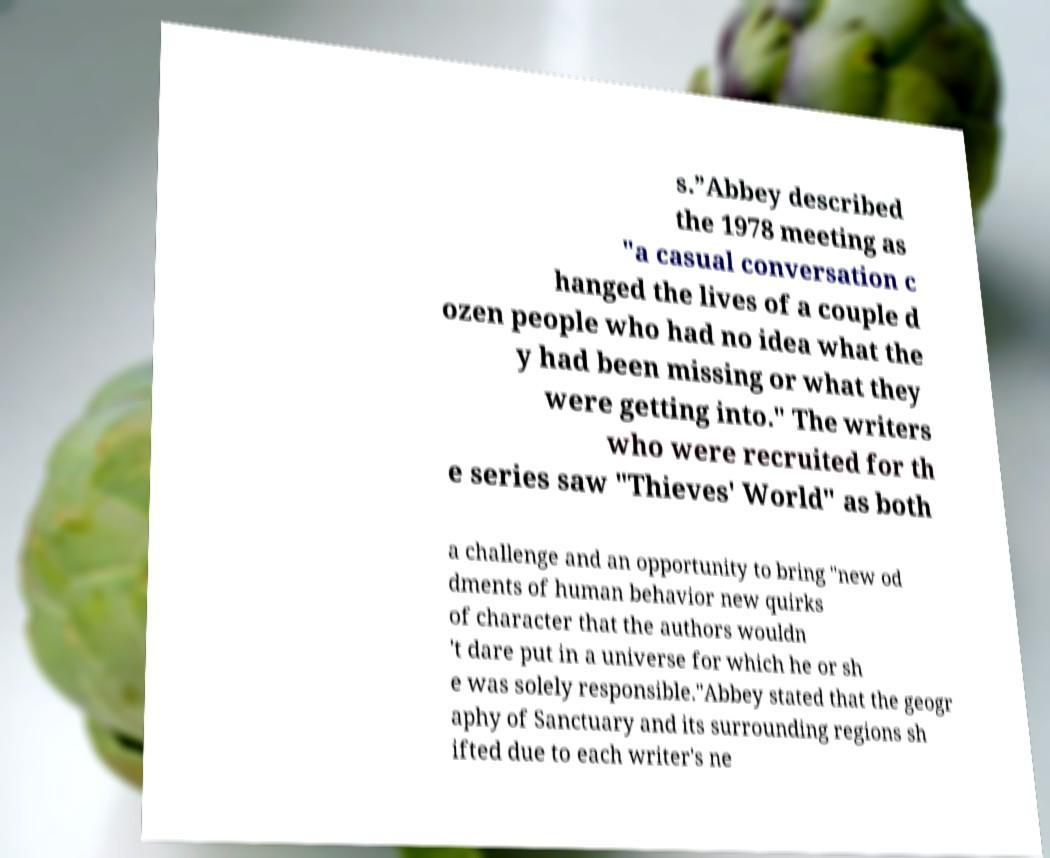Please identify and transcribe the text found in this image. s.”Abbey described the 1978 meeting as "a casual conversation c hanged the lives of a couple d ozen people who had no idea what the y had been missing or what they were getting into." The writers who were recruited for th e series saw "Thieves' World" as both a challenge and an opportunity to bring "new od dments of human behavior new quirks of character that the authors wouldn 't dare put in a universe for which he or sh e was solely responsible."Abbey stated that the geogr aphy of Sanctuary and its surrounding regions sh ifted due to each writer's ne 